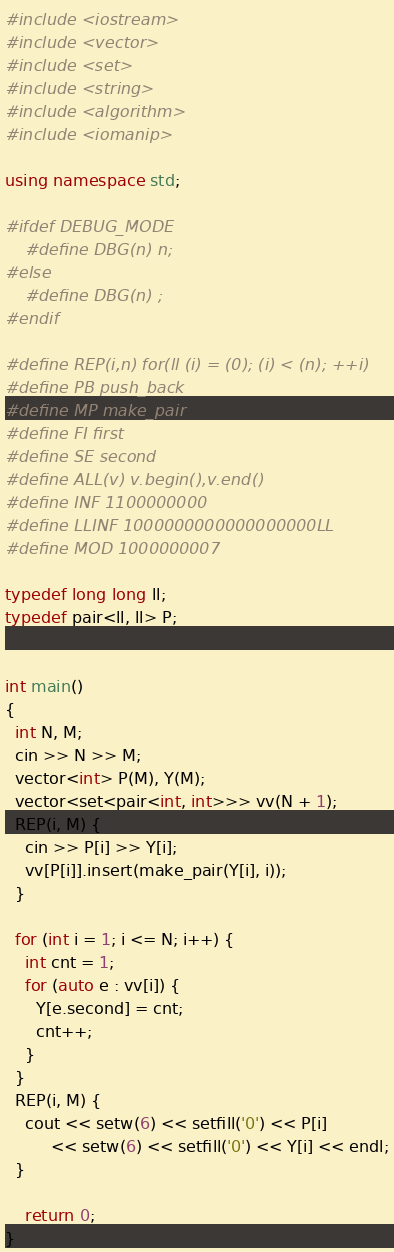<code> <loc_0><loc_0><loc_500><loc_500><_C++_>#include <iostream>
#include <vector>
#include <set>
#include <string>
#include <algorithm>
#include <iomanip>

using namespace std;

#ifdef DEBUG_MODE
	#define DBG(n) n;
#else
	#define DBG(n) ;
#endif

#define REP(i,n) for(ll (i) = (0); (i) < (n); ++i)
#define PB push_back
#define MP make_pair
#define FI first
#define SE second
#define ALL(v) v.begin(),v.end()
#define INF 1100000000
#define LLINF 1000000000000000000LL
#define MOD 1000000007

typedef long long ll;
typedef pair<ll, ll> P;


int main()
{
  int N, M;
  cin >> N >> M;
  vector<int> P(M), Y(M);
  vector<set<pair<int, int>>> vv(N + 1);
  REP(i, M) {
    cin >> P[i] >> Y[i];
    vv[P[i]].insert(make_pair(Y[i], i));
  }

  for (int i = 1; i <= N; i++) {
    int cnt = 1;
    for (auto e : vv[i]) {
      Y[e.second] = cnt;
      cnt++;
    }
  }
  REP(i, M) {
    cout << setw(6) << setfill('0') << P[i] 
         << setw(6) << setfill('0') << Y[i] << endl;
  }

	return 0;
}

</code> 